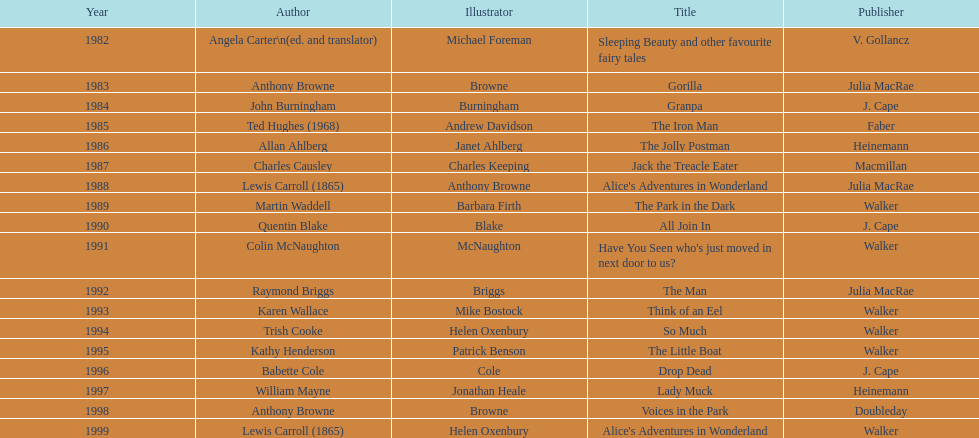Which author wrote the first award winner? Angela Carter. 